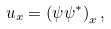<formula> <loc_0><loc_0><loc_500><loc_500>u _ { x } = \left ( \psi \psi ^ { \ast } \right ) _ { x } ,</formula> 